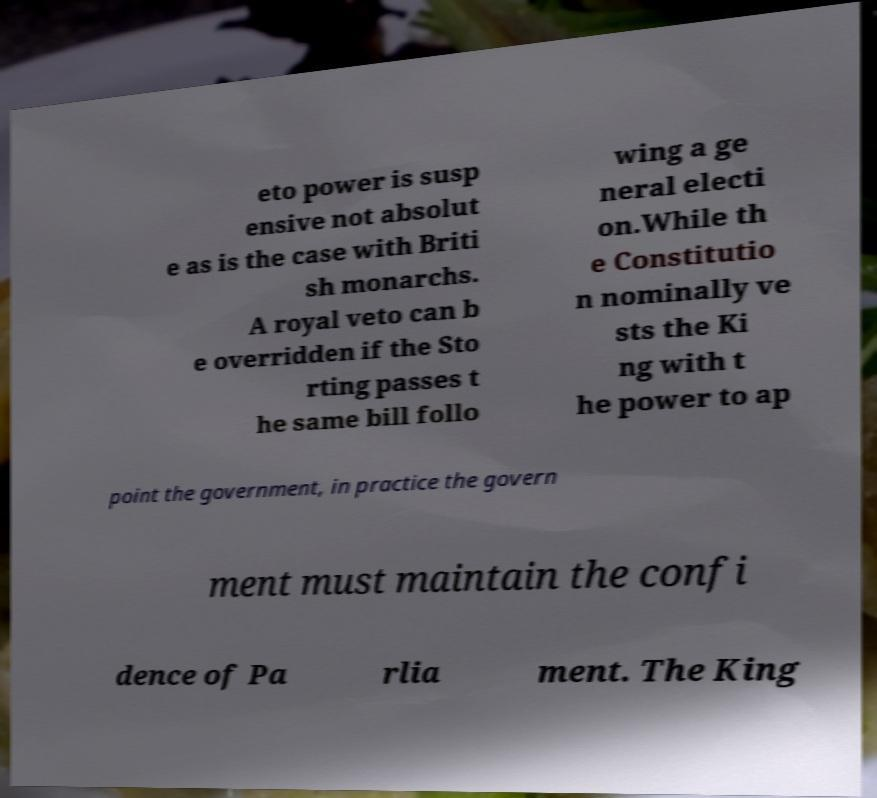For documentation purposes, I need the text within this image transcribed. Could you provide that? eto power is susp ensive not absolut e as is the case with Briti sh monarchs. A royal veto can b e overridden if the Sto rting passes t he same bill follo wing a ge neral electi on.While th e Constitutio n nominally ve sts the Ki ng with t he power to ap point the government, in practice the govern ment must maintain the confi dence of Pa rlia ment. The King 